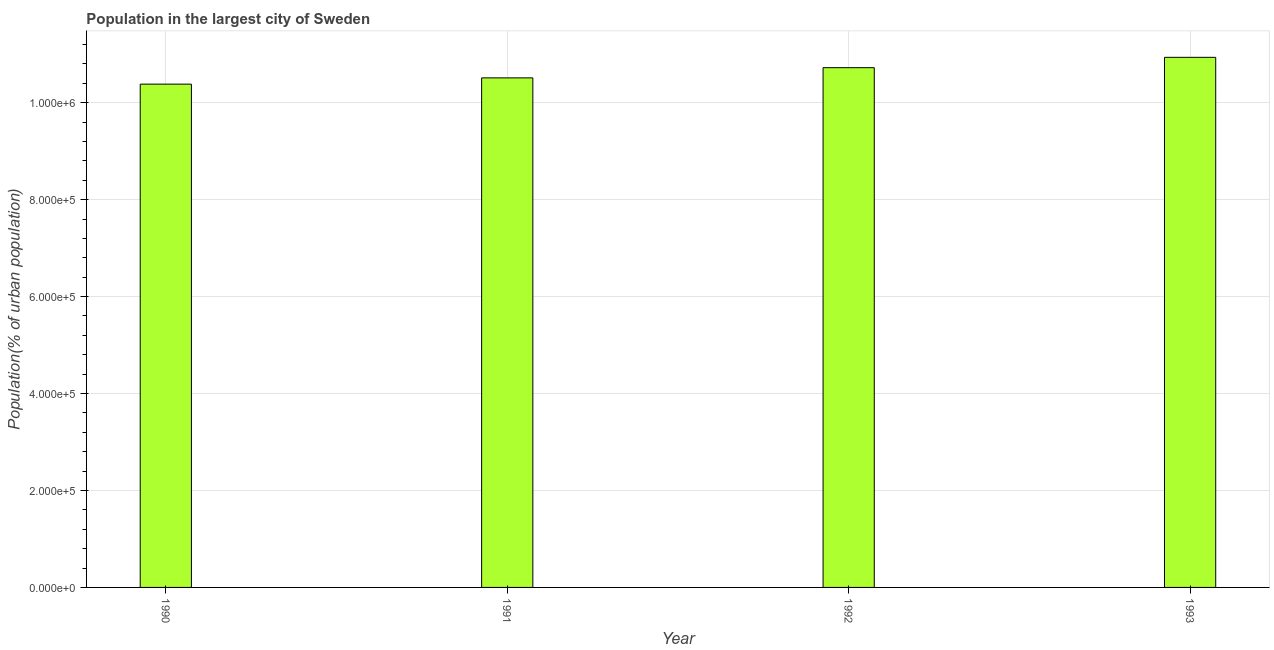Does the graph contain any zero values?
Provide a succinct answer. No. Does the graph contain grids?
Provide a short and direct response. Yes. What is the title of the graph?
Offer a very short reply. Population in the largest city of Sweden. What is the label or title of the Y-axis?
Your answer should be very brief. Population(% of urban population). What is the population in largest city in 1990?
Provide a short and direct response. 1.04e+06. Across all years, what is the maximum population in largest city?
Keep it short and to the point. 1.09e+06. Across all years, what is the minimum population in largest city?
Provide a short and direct response. 1.04e+06. In which year was the population in largest city maximum?
Offer a terse response. 1993. In which year was the population in largest city minimum?
Your response must be concise. 1990. What is the sum of the population in largest city?
Your answer should be compact. 4.26e+06. What is the difference between the population in largest city in 1990 and 1991?
Offer a very short reply. -1.29e+04. What is the average population in largest city per year?
Provide a short and direct response. 1.06e+06. What is the median population in largest city?
Give a very brief answer. 1.06e+06. Do a majority of the years between 1991 and 1990 (inclusive) have population in largest city greater than 720000 %?
Offer a terse response. No. What is the ratio of the population in largest city in 1991 to that in 1992?
Offer a very short reply. 0.98. Is the difference between the population in largest city in 1990 and 1992 greater than the difference between any two years?
Make the answer very short. No. What is the difference between the highest and the second highest population in largest city?
Your response must be concise. 2.14e+04. What is the difference between the highest and the lowest population in largest city?
Your answer should be compact. 5.53e+04. How many bars are there?
Offer a very short reply. 4. How many years are there in the graph?
Make the answer very short. 4. Are the values on the major ticks of Y-axis written in scientific E-notation?
Keep it short and to the point. Yes. What is the Population(% of urban population) of 1990?
Give a very brief answer. 1.04e+06. What is the Population(% of urban population) in 1991?
Provide a succinct answer. 1.05e+06. What is the Population(% of urban population) of 1992?
Provide a succinct answer. 1.07e+06. What is the Population(% of urban population) in 1993?
Give a very brief answer. 1.09e+06. What is the difference between the Population(% of urban population) in 1990 and 1991?
Give a very brief answer. -1.29e+04. What is the difference between the Population(% of urban population) in 1990 and 1992?
Provide a succinct answer. -3.39e+04. What is the difference between the Population(% of urban population) in 1990 and 1993?
Your answer should be compact. -5.53e+04. What is the difference between the Population(% of urban population) in 1991 and 1992?
Provide a short and direct response. -2.10e+04. What is the difference between the Population(% of urban population) in 1991 and 1993?
Your response must be concise. -4.24e+04. What is the difference between the Population(% of urban population) in 1992 and 1993?
Keep it short and to the point. -2.14e+04. What is the ratio of the Population(% of urban population) in 1990 to that in 1991?
Ensure brevity in your answer.  0.99. What is the ratio of the Population(% of urban population) in 1990 to that in 1992?
Provide a succinct answer. 0.97. What is the ratio of the Population(% of urban population) in 1990 to that in 1993?
Your response must be concise. 0.95. What is the ratio of the Population(% of urban population) in 1991 to that in 1993?
Your answer should be compact. 0.96. What is the ratio of the Population(% of urban population) in 1992 to that in 1993?
Make the answer very short. 0.98. 